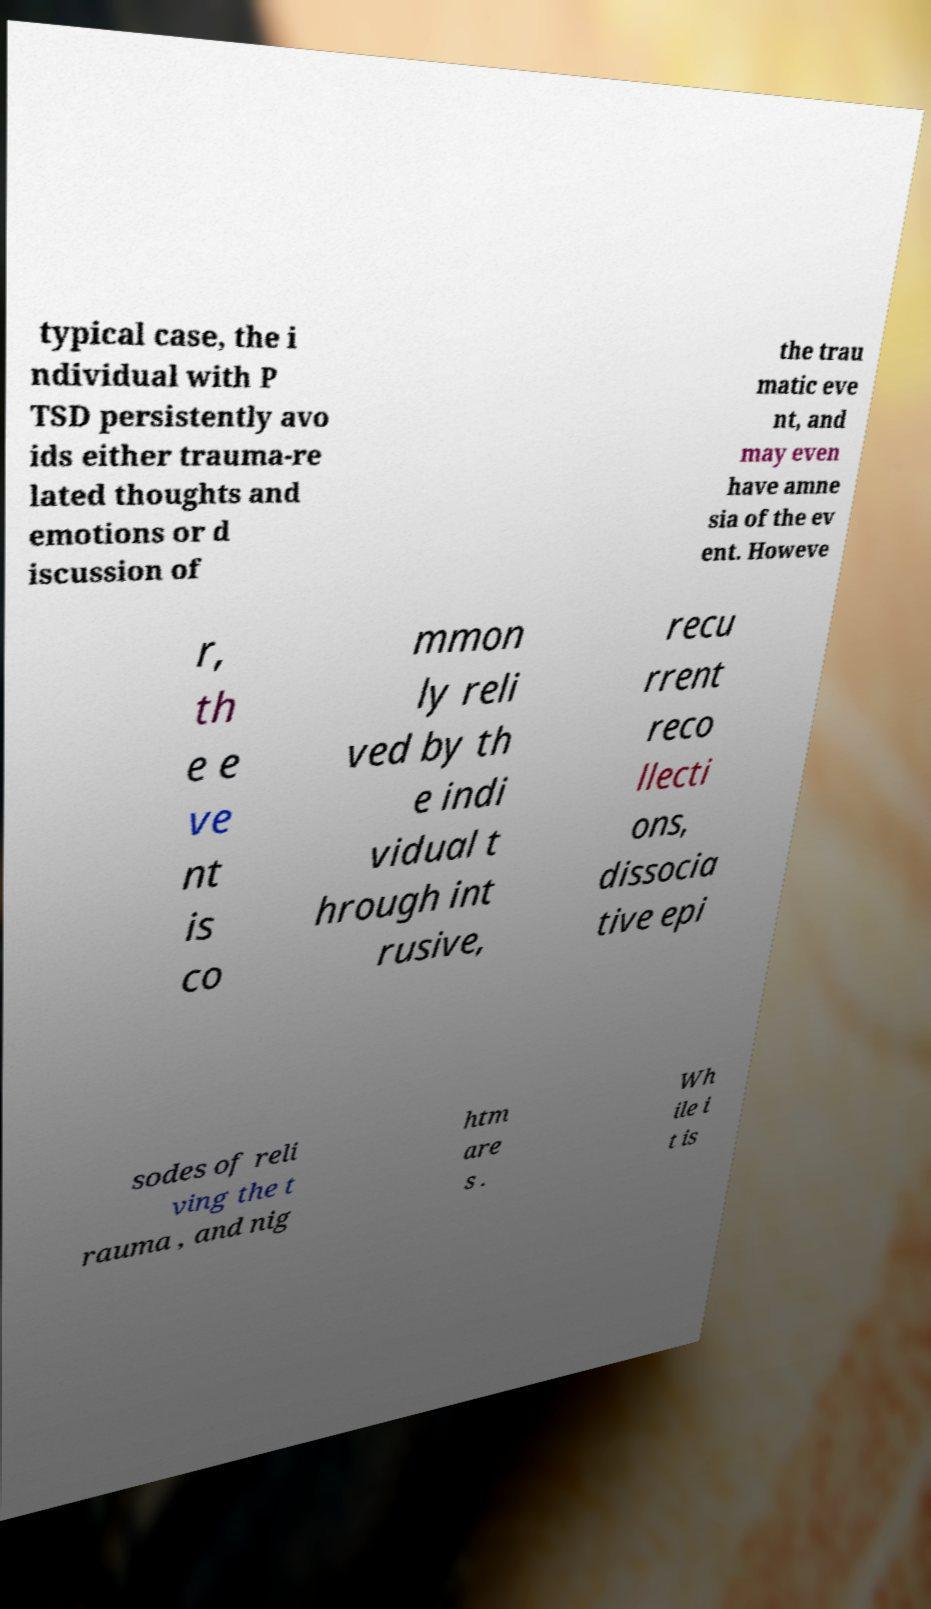For documentation purposes, I need the text within this image transcribed. Could you provide that? typical case, the i ndividual with P TSD persistently avo ids either trauma-re lated thoughts and emotions or d iscussion of the trau matic eve nt, and may even have amne sia of the ev ent. Howeve r, th e e ve nt is co mmon ly reli ved by th e indi vidual t hrough int rusive, recu rrent reco llecti ons, dissocia tive epi sodes of reli ving the t rauma , and nig htm are s . Wh ile i t is 